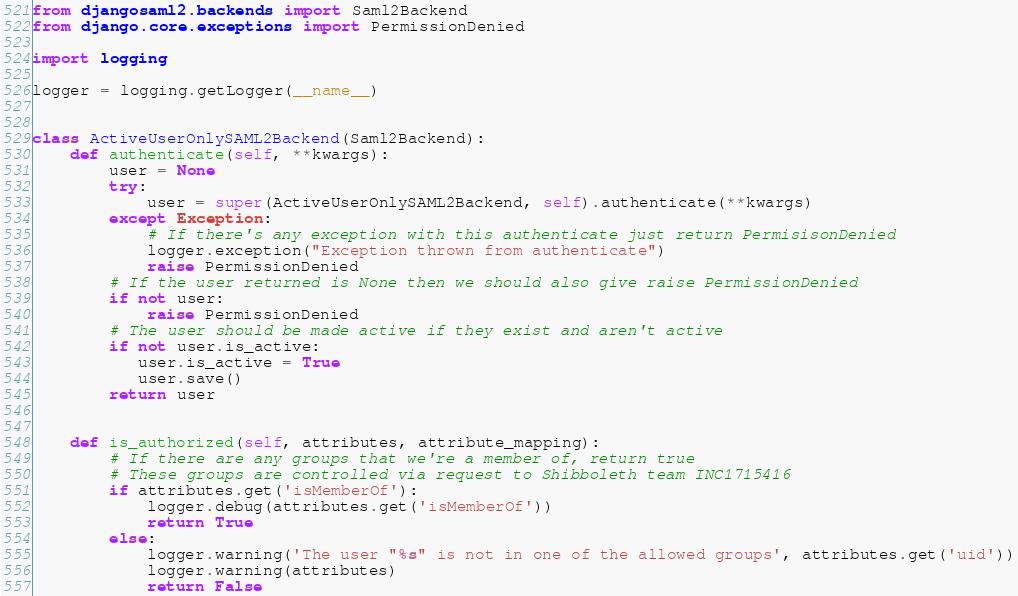Convert code to text. <code><loc_0><loc_0><loc_500><loc_500><_Python_>from djangosaml2.backends import Saml2Backend
from django.core.exceptions import PermissionDenied

import logging

logger = logging.getLogger(__name__)


class ActiveUserOnlySAML2Backend(Saml2Backend):
    def authenticate(self, **kwargs):
        user = None
        try:
            user = super(ActiveUserOnlySAML2Backend, self).authenticate(**kwargs)
        except Exception:
            # If there's any exception with this authenticate just return PermisisonDenied
            logger.exception("Exception thrown from authenticate")
            raise PermissionDenied
        # If the user returned is None then we should also give raise PermissionDenied
        if not user:
            raise PermissionDenied
        # The user should be made active if they exist and aren't active
        if not user.is_active:
           user.is_active = True
           user.save()
        return user
            

    def is_authorized(self, attributes, attribute_mapping):
        # If there are any groups that we're a member of, return true
        # These groups are controlled via request to Shibboleth team INC1715416
        if attributes.get('isMemberOf'):
            logger.debug(attributes.get('isMemberOf'))
            return True
        else:
            logger.warning('The user "%s" is not in one of the allowed groups', attributes.get('uid'))
            logger.warning(attributes)
            return False 
</code> 